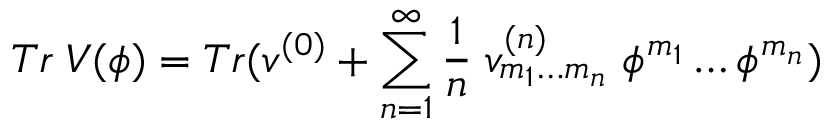<formula> <loc_0><loc_0><loc_500><loc_500>T r \, V ( \phi ) = T r ( v ^ { ( 0 ) } + \sum _ { n = 1 } ^ { \infty } \frac { 1 } { n } \, v _ { m _ { 1 } \dots m _ { n } } ^ { ( n ) } \, \phi ^ { m _ { 1 } } \dots \phi ^ { m _ { n } } )</formula> 